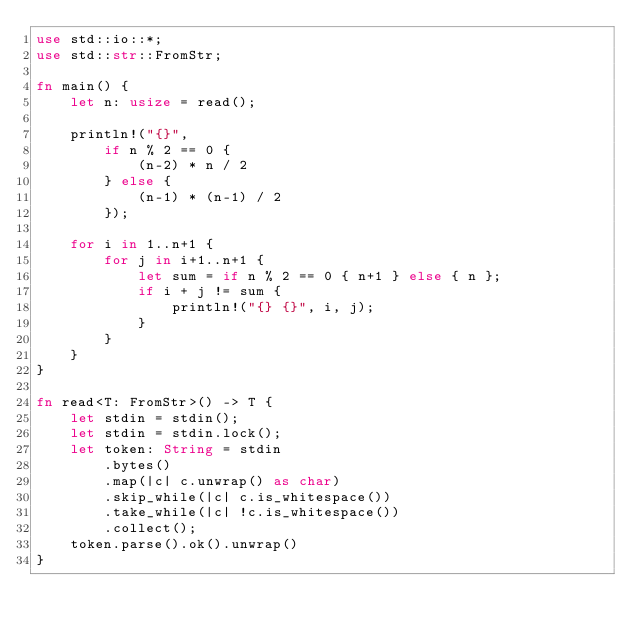<code> <loc_0><loc_0><loc_500><loc_500><_Rust_>use std::io::*;
use std::str::FromStr;

fn main() {
    let n: usize = read();

    println!("{}",
        if n % 2 == 0 {
            (n-2) * n / 2
        } else {
            (n-1) * (n-1) / 2
        });
        
    for i in 1..n+1 {
        for j in i+1..n+1 {
            let sum = if n % 2 == 0 { n+1 } else { n };
            if i + j != sum {
                println!("{} {}", i, j);
            }
        }
    }
}

fn read<T: FromStr>() -> T {
    let stdin = stdin();
    let stdin = stdin.lock();
    let token: String = stdin
        .bytes()
        .map(|c| c.unwrap() as char)
        .skip_while(|c| c.is_whitespace())
        .take_while(|c| !c.is_whitespace())
        .collect();
    token.parse().ok().unwrap()
}
</code> 